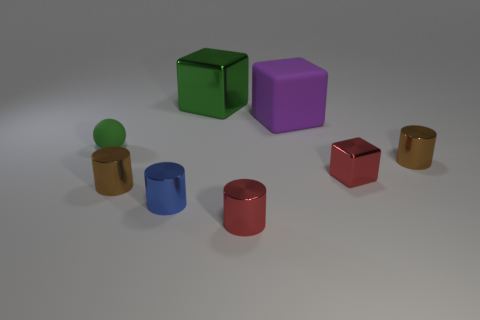Do the ball and the big metal cube have the same color?
Provide a short and direct response. Yes. There is a object that is the same color as the tiny ball; what shape is it?
Your answer should be compact. Cube. What number of things are tiny brown metal cylinders or small cylinders right of the big purple rubber object?
Your answer should be very brief. 2. The green sphere that is made of the same material as the big purple object is what size?
Offer a terse response. Small. Is the number of tiny brown metallic cylinders that are to the left of the big green metallic object greater than the number of tiny brown rubber cylinders?
Provide a succinct answer. Yes. There is a metallic object that is both behind the red cube and in front of the large green thing; what size is it?
Give a very brief answer. Small. What is the material of the other red thing that is the same shape as the large matte object?
Give a very brief answer. Metal. Do the brown thing that is on the right side of the green cube and the large matte object have the same size?
Make the answer very short. No. There is a small object that is both behind the small cube and to the right of the big purple matte block; what is its color?
Offer a terse response. Brown. There is a red thing that is to the left of the large matte thing; what number of matte things are on the right side of it?
Your answer should be compact. 1. 